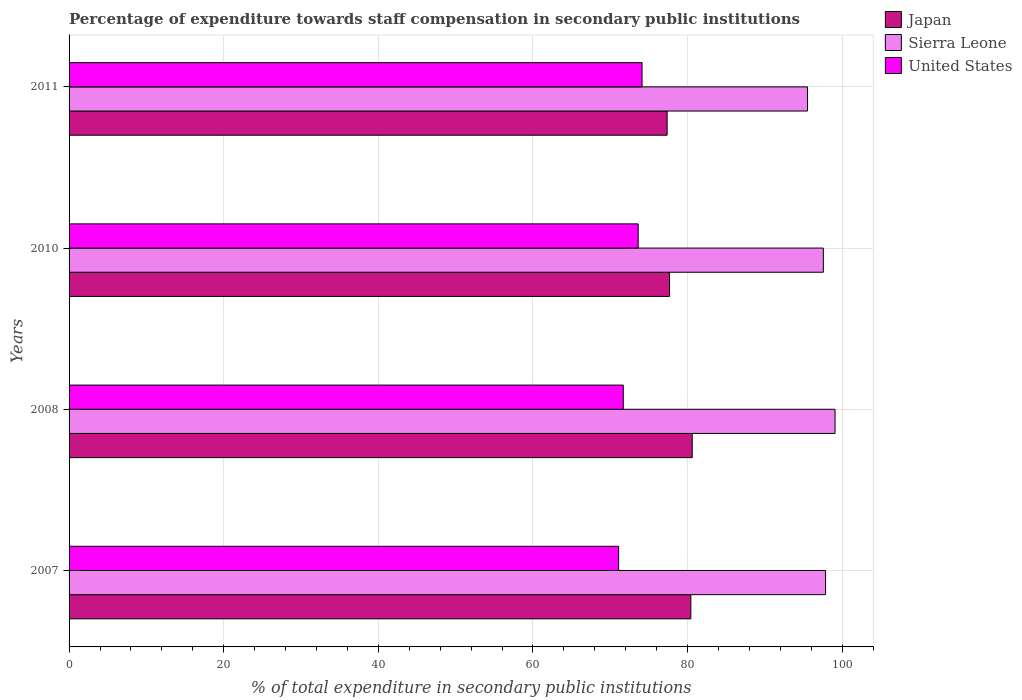How many groups of bars are there?
Provide a succinct answer. 4. Are the number of bars per tick equal to the number of legend labels?
Your response must be concise. Yes. Are the number of bars on each tick of the Y-axis equal?
Ensure brevity in your answer.  Yes. How many bars are there on the 1st tick from the top?
Ensure brevity in your answer.  3. What is the percentage of expenditure towards staff compensation in United States in 2007?
Your answer should be very brief. 71.09. Across all years, what is the maximum percentage of expenditure towards staff compensation in Sierra Leone?
Provide a short and direct response. 99.08. Across all years, what is the minimum percentage of expenditure towards staff compensation in Sierra Leone?
Make the answer very short. 95.52. What is the total percentage of expenditure towards staff compensation in United States in the graph?
Keep it short and to the point. 290.51. What is the difference between the percentage of expenditure towards staff compensation in United States in 2010 and that in 2011?
Ensure brevity in your answer.  -0.5. What is the difference between the percentage of expenditure towards staff compensation in Japan in 2010 and the percentage of expenditure towards staff compensation in United States in 2007?
Make the answer very short. 6.59. What is the average percentage of expenditure towards staff compensation in Japan per year?
Offer a terse response. 79.02. In the year 2007, what is the difference between the percentage of expenditure towards staff compensation in Japan and percentage of expenditure towards staff compensation in United States?
Offer a very short reply. 9.34. In how many years, is the percentage of expenditure towards staff compensation in Japan greater than 16 %?
Offer a very short reply. 4. What is the ratio of the percentage of expenditure towards staff compensation in Sierra Leone in 2008 to that in 2010?
Your answer should be very brief. 1.02. Is the percentage of expenditure towards staff compensation in Sierra Leone in 2008 less than that in 2011?
Give a very brief answer. No. What is the difference between the highest and the second highest percentage of expenditure towards staff compensation in Sierra Leone?
Provide a short and direct response. 1.23. What is the difference between the highest and the lowest percentage of expenditure towards staff compensation in Japan?
Ensure brevity in your answer.  3.25. Is the sum of the percentage of expenditure towards staff compensation in United States in 2007 and 2010 greater than the maximum percentage of expenditure towards staff compensation in Sierra Leone across all years?
Ensure brevity in your answer.  Yes. What does the 2nd bar from the top in 2011 represents?
Provide a succinct answer. Sierra Leone. What does the 3rd bar from the bottom in 2010 represents?
Ensure brevity in your answer.  United States. Is it the case that in every year, the sum of the percentage of expenditure towards staff compensation in Sierra Leone and percentage of expenditure towards staff compensation in United States is greater than the percentage of expenditure towards staff compensation in Japan?
Keep it short and to the point. Yes. How many bars are there?
Your answer should be compact. 12. Does the graph contain any zero values?
Give a very brief answer. No. Does the graph contain grids?
Your answer should be compact. Yes. Where does the legend appear in the graph?
Give a very brief answer. Top right. How are the legend labels stacked?
Keep it short and to the point. Vertical. What is the title of the graph?
Give a very brief answer. Percentage of expenditure towards staff compensation in secondary public institutions. Does "Philippines" appear as one of the legend labels in the graph?
Your answer should be compact. No. What is the label or title of the X-axis?
Your answer should be compact. % of total expenditure in secondary public institutions. What is the label or title of the Y-axis?
Your response must be concise. Years. What is the % of total expenditure in secondary public institutions of Japan in 2007?
Give a very brief answer. 80.43. What is the % of total expenditure in secondary public institutions in Sierra Leone in 2007?
Provide a short and direct response. 97.85. What is the % of total expenditure in secondary public institutions of United States in 2007?
Provide a short and direct response. 71.09. What is the % of total expenditure in secondary public institutions of Japan in 2008?
Your answer should be very brief. 80.61. What is the % of total expenditure in secondary public institutions in Sierra Leone in 2008?
Offer a terse response. 99.08. What is the % of total expenditure in secondary public institutions in United States in 2008?
Your answer should be compact. 71.69. What is the % of total expenditure in secondary public institutions of Japan in 2010?
Your answer should be compact. 77.68. What is the % of total expenditure in secondary public institutions in Sierra Leone in 2010?
Provide a succinct answer. 97.57. What is the % of total expenditure in secondary public institutions of United States in 2010?
Offer a very short reply. 73.62. What is the % of total expenditure in secondary public institutions of Japan in 2011?
Keep it short and to the point. 77.36. What is the % of total expenditure in secondary public institutions of Sierra Leone in 2011?
Offer a terse response. 95.52. What is the % of total expenditure in secondary public institutions of United States in 2011?
Ensure brevity in your answer.  74.12. Across all years, what is the maximum % of total expenditure in secondary public institutions in Japan?
Provide a short and direct response. 80.61. Across all years, what is the maximum % of total expenditure in secondary public institutions in Sierra Leone?
Make the answer very short. 99.08. Across all years, what is the maximum % of total expenditure in secondary public institutions of United States?
Provide a short and direct response. 74.12. Across all years, what is the minimum % of total expenditure in secondary public institutions in Japan?
Offer a terse response. 77.36. Across all years, what is the minimum % of total expenditure in secondary public institutions of Sierra Leone?
Offer a terse response. 95.52. Across all years, what is the minimum % of total expenditure in secondary public institutions of United States?
Give a very brief answer. 71.09. What is the total % of total expenditure in secondary public institutions of Japan in the graph?
Your answer should be very brief. 316.07. What is the total % of total expenditure in secondary public institutions of Sierra Leone in the graph?
Provide a short and direct response. 390.03. What is the total % of total expenditure in secondary public institutions of United States in the graph?
Provide a short and direct response. 290.51. What is the difference between the % of total expenditure in secondary public institutions of Japan in 2007 and that in 2008?
Ensure brevity in your answer.  -0.18. What is the difference between the % of total expenditure in secondary public institutions of Sierra Leone in 2007 and that in 2008?
Your response must be concise. -1.23. What is the difference between the % of total expenditure in secondary public institutions in United States in 2007 and that in 2008?
Ensure brevity in your answer.  -0.6. What is the difference between the % of total expenditure in secondary public institutions of Japan in 2007 and that in 2010?
Your answer should be compact. 2.75. What is the difference between the % of total expenditure in secondary public institutions of Sierra Leone in 2007 and that in 2010?
Your answer should be very brief. 0.29. What is the difference between the % of total expenditure in secondary public institutions in United States in 2007 and that in 2010?
Make the answer very short. -2.53. What is the difference between the % of total expenditure in secondary public institutions in Japan in 2007 and that in 2011?
Keep it short and to the point. 3.07. What is the difference between the % of total expenditure in secondary public institutions in Sierra Leone in 2007 and that in 2011?
Provide a short and direct response. 2.33. What is the difference between the % of total expenditure in secondary public institutions of United States in 2007 and that in 2011?
Provide a short and direct response. -3.03. What is the difference between the % of total expenditure in secondary public institutions of Japan in 2008 and that in 2010?
Keep it short and to the point. 2.93. What is the difference between the % of total expenditure in secondary public institutions of Sierra Leone in 2008 and that in 2010?
Keep it short and to the point. 1.51. What is the difference between the % of total expenditure in secondary public institutions of United States in 2008 and that in 2010?
Give a very brief answer. -1.93. What is the difference between the % of total expenditure in secondary public institutions of Japan in 2008 and that in 2011?
Your answer should be very brief. 3.25. What is the difference between the % of total expenditure in secondary public institutions of Sierra Leone in 2008 and that in 2011?
Provide a succinct answer. 3.56. What is the difference between the % of total expenditure in secondary public institutions of United States in 2008 and that in 2011?
Give a very brief answer. -2.43. What is the difference between the % of total expenditure in secondary public institutions of Japan in 2010 and that in 2011?
Your answer should be very brief. 0.32. What is the difference between the % of total expenditure in secondary public institutions of Sierra Leone in 2010 and that in 2011?
Your response must be concise. 2.05. What is the difference between the % of total expenditure in secondary public institutions of United States in 2010 and that in 2011?
Make the answer very short. -0.5. What is the difference between the % of total expenditure in secondary public institutions in Japan in 2007 and the % of total expenditure in secondary public institutions in Sierra Leone in 2008?
Give a very brief answer. -18.65. What is the difference between the % of total expenditure in secondary public institutions of Japan in 2007 and the % of total expenditure in secondary public institutions of United States in 2008?
Offer a terse response. 8.74. What is the difference between the % of total expenditure in secondary public institutions of Sierra Leone in 2007 and the % of total expenditure in secondary public institutions of United States in 2008?
Make the answer very short. 26.17. What is the difference between the % of total expenditure in secondary public institutions of Japan in 2007 and the % of total expenditure in secondary public institutions of Sierra Leone in 2010?
Offer a terse response. -17.14. What is the difference between the % of total expenditure in secondary public institutions in Japan in 2007 and the % of total expenditure in secondary public institutions in United States in 2010?
Ensure brevity in your answer.  6.81. What is the difference between the % of total expenditure in secondary public institutions of Sierra Leone in 2007 and the % of total expenditure in secondary public institutions of United States in 2010?
Offer a terse response. 24.24. What is the difference between the % of total expenditure in secondary public institutions in Japan in 2007 and the % of total expenditure in secondary public institutions in Sierra Leone in 2011?
Make the answer very short. -15.1. What is the difference between the % of total expenditure in secondary public institutions of Japan in 2007 and the % of total expenditure in secondary public institutions of United States in 2011?
Offer a very short reply. 6.31. What is the difference between the % of total expenditure in secondary public institutions of Sierra Leone in 2007 and the % of total expenditure in secondary public institutions of United States in 2011?
Keep it short and to the point. 23.74. What is the difference between the % of total expenditure in secondary public institutions of Japan in 2008 and the % of total expenditure in secondary public institutions of Sierra Leone in 2010?
Give a very brief answer. -16.96. What is the difference between the % of total expenditure in secondary public institutions of Japan in 2008 and the % of total expenditure in secondary public institutions of United States in 2010?
Your response must be concise. 6.99. What is the difference between the % of total expenditure in secondary public institutions of Sierra Leone in 2008 and the % of total expenditure in secondary public institutions of United States in 2010?
Offer a very short reply. 25.47. What is the difference between the % of total expenditure in secondary public institutions of Japan in 2008 and the % of total expenditure in secondary public institutions of Sierra Leone in 2011?
Provide a short and direct response. -14.91. What is the difference between the % of total expenditure in secondary public institutions in Japan in 2008 and the % of total expenditure in secondary public institutions in United States in 2011?
Ensure brevity in your answer.  6.49. What is the difference between the % of total expenditure in secondary public institutions of Sierra Leone in 2008 and the % of total expenditure in secondary public institutions of United States in 2011?
Give a very brief answer. 24.96. What is the difference between the % of total expenditure in secondary public institutions of Japan in 2010 and the % of total expenditure in secondary public institutions of Sierra Leone in 2011?
Provide a short and direct response. -17.85. What is the difference between the % of total expenditure in secondary public institutions in Japan in 2010 and the % of total expenditure in secondary public institutions in United States in 2011?
Your response must be concise. 3.56. What is the difference between the % of total expenditure in secondary public institutions in Sierra Leone in 2010 and the % of total expenditure in secondary public institutions in United States in 2011?
Provide a short and direct response. 23.45. What is the average % of total expenditure in secondary public institutions of Japan per year?
Offer a terse response. 79.02. What is the average % of total expenditure in secondary public institutions in Sierra Leone per year?
Your response must be concise. 97.51. What is the average % of total expenditure in secondary public institutions of United States per year?
Keep it short and to the point. 72.63. In the year 2007, what is the difference between the % of total expenditure in secondary public institutions of Japan and % of total expenditure in secondary public institutions of Sierra Leone?
Your response must be concise. -17.43. In the year 2007, what is the difference between the % of total expenditure in secondary public institutions of Japan and % of total expenditure in secondary public institutions of United States?
Provide a short and direct response. 9.34. In the year 2007, what is the difference between the % of total expenditure in secondary public institutions of Sierra Leone and % of total expenditure in secondary public institutions of United States?
Your answer should be very brief. 26.77. In the year 2008, what is the difference between the % of total expenditure in secondary public institutions in Japan and % of total expenditure in secondary public institutions in Sierra Leone?
Your answer should be very brief. -18.47. In the year 2008, what is the difference between the % of total expenditure in secondary public institutions in Japan and % of total expenditure in secondary public institutions in United States?
Give a very brief answer. 8.92. In the year 2008, what is the difference between the % of total expenditure in secondary public institutions in Sierra Leone and % of total expenditure in secondary public institutions in United States?
Your response must be concise. 27.39. In the year 2010, what is the difference between the % of total expenditure in secondary public institutions of Japan and % of total expenditure in secondary public institutions of Sierra Leone?
Provide a succinct answer. -19.89. In the year 2010, what is the difference between the % of total expenditure in secondary public institutions in Japan and % of total expenditure in secondary public institutions in United States?
Your answer should be compact. 4.06. In the year 2010, what is the difference between the % of total expenditure in secondary public institutions of Sierra Leone and % of total expenditure in secondary public institutions of United States?
Give a very brief answer. 23.95. In the year 2011, what is the difference between the % of total expenditure in secondary public institutions of Japan and % of total expenditure in secondary public institutions of Sierra Leone?
Your answer should be compact. -18.16. In the year 2011, what is the difference between the % of total expenditure in secondary public institutions in Japan and % of total expenditure in secondary public institutions in United States?
Make the answer very short. 3.24. In the year 2011, what is the difference between the % of total expenditure in secondary public institutions of Sierra Leone and % of total expenditure in secondary public institutions of United States?
Provide a short and direct response. 21.4. What is the ratio of the % of total expenditure in secondary public institutions of Japan in 2007 to that in 2008?
Make the answer very short. 1. What is the ratio of the % of total expenditure in secondary public institutions of Sierra Leone in 2007 to that in 2008?
Give a very brief answer. 0.99. What is the ratio of the % of total expenditure in secondary public institutions in Japan in 2007 to that in 2010?
Your response must be concise. 1.04. What is the ratio of the % of total expenditure in secondary public institutions of United States in 2007 to that in 2010?
Your answer should be compact. 0.97. What is the ratio of the % of total expenditure in secondary public institutions of Japan in 2007 to that in 2011?
Make the answer very short. 1.04. What is the ratio of the % of total expenditure in secondary public institutions in Sierra Leone in 2007 to that in 2011?
Make the answer very short. 1.02. What is the ratio of the % of total expenditure in secondary public institutions of United States in 2007 to that in 2011?
Offer a very short reply. 0.96. What is the ratio of the % of total expenditure in secondary public institutions of Japan in 2008 to that in 2010?
Provide a succinct answer. 1.04. What is the ratio of the % of total expenditure in secondary public institutions of Sierra Leone in 2008 to that in 2010?
Make the answer very short. 1.02. What is the ratio of the % of total expenditure in secondary public institutions of United States in 2008 to that in 2010?
Offer a very short reply. 0.97. What is the ratio of the % of total expenditure in secondary public institutions in Japan in 2008 to that in 2011?
Keep it short and to the point. 1.04. What is the ratio of the % of total expenditure in secondary public institutions in Sierra Leone in 2008 to that in 2011?
Your answer should be compact. 1.04. What is the ratio of the % of total expenditure in secondary public institutions in United States in 2008 to that in 2011?
Provide a succinct answer. 0.97. What is the ratio of the % of total expenditure in secondary public institutions of Japan in 2010 to that in 2011?
Offer a terse response. 1. What is the ratio of the % of total expenditure in secondary public institutions of Sierra Leone in 2010 to that in 2011?
Offer a terse response. 1.02. What is the ratio of the % of total expenditure in secondary public institutions of United States in 2010 to that in 2011?
Provide a succinct answer. 0.99. What is the difference between the highest and the second highest % of total expenditure in secondary public institutions of Japan?
Your answer should be very brief. 0.18. What is the difference between the highest and the second highest % of total expenditure in secondary public institutions of Sierra Leone?
Give a very brief answer. 1.23. What is the difference between the highest and the second highest % of total expenditure in secondary public institutions of United States?
Your answer should be compact. 0.5. What is the difference between the highest and the lowest % of total expenditure in secondary public institutions of Japan?
Your response must be concise. 3.25. What is the difference between the highest and the lowest % of total expenditure in secondary public institutions of Sierra Leone?
Provide a short and direct response. 3.56. What is the difference between the highest and the lowest % of total expenditure in secondary public institutions of United States?
Your answer should be very brief. 3.03. 